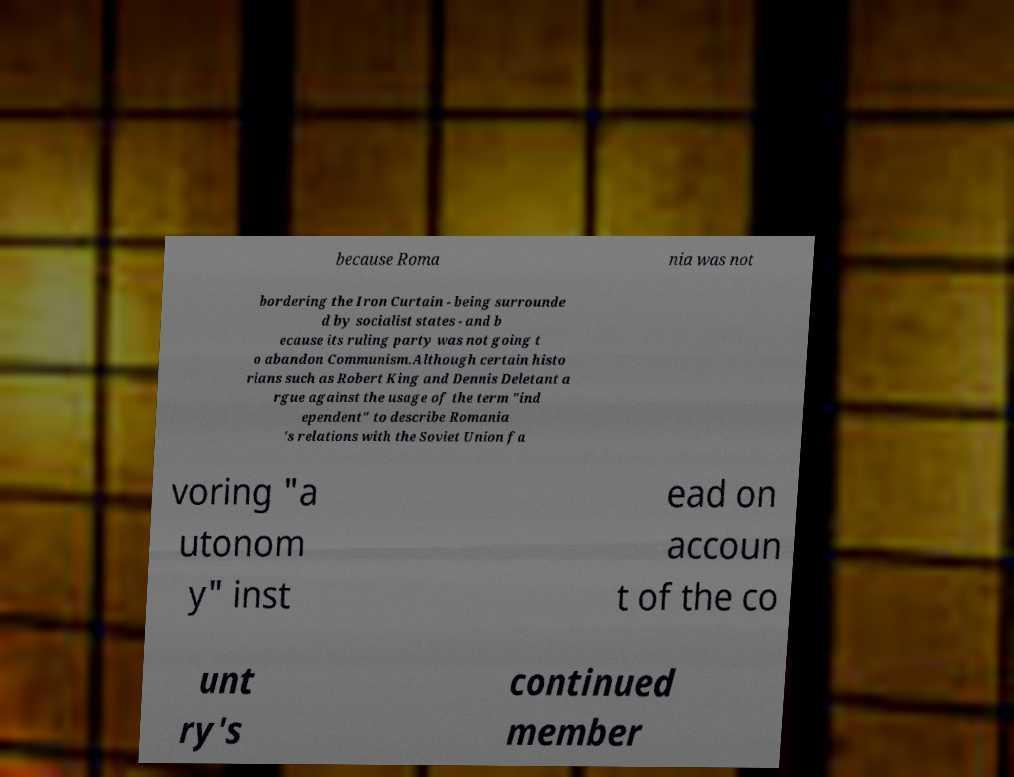There's text embedded in this image that I need extracted. Can you transcribe it verbatim? because Roma nia was not bordering the Iron Curtain - being surrounde d by socialist states - and b ecause its ruling party was not going t o abandon Communism.Although certain histo rians such as Robert King and Dennis Deletant a rgue against the usage of the term "ind ependent" to describe Romania 's relations with the Soviet Union fa voring "a utonom y" inst ead on accoun t of the co unt ry's continued member 